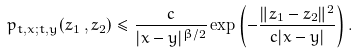<formula> <loc_0><loc_0><loc_500><loc_500>p _ { t , x ; t , y } ( z _ { 1 } \, , z _ { 2 } ) \leq \frac { c } { | x - y | ^ { \beta / 2 } } \exp \left ( - \frac { \| z _ { 1 } - z _ { 2 } \| ^ { 2 } } { c | x - y | } \right ) .</formula> 